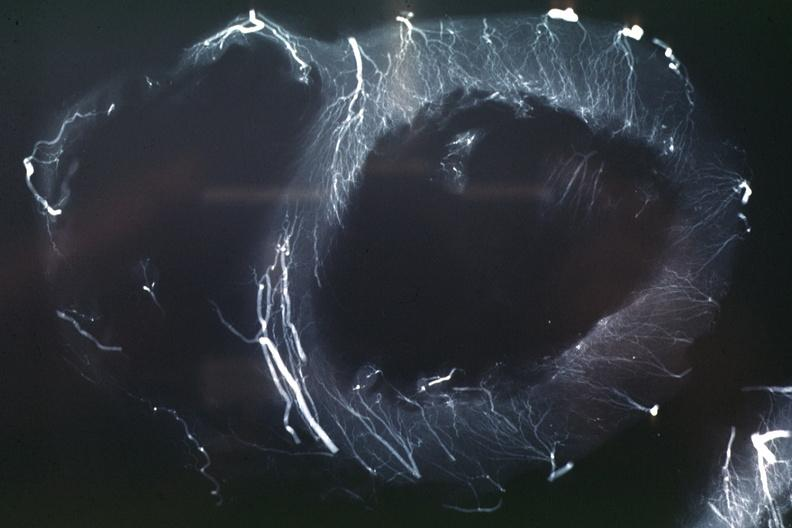does this image show x-ray postmortinjection horizontal slice of left ventricle showing very well penetrating arteries?
Answer the question using a single word or phrase. Yes 